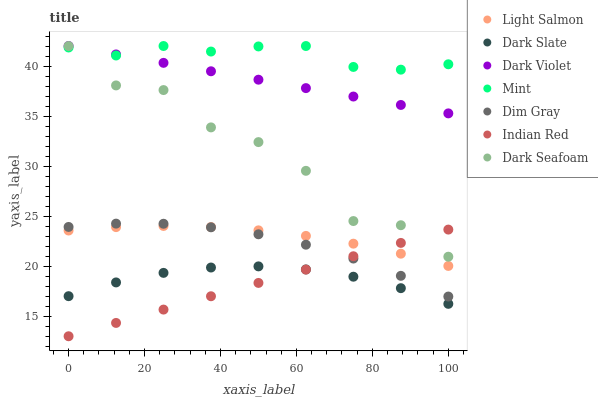Does Indian Red have the minimum area under the curve?
Answer yes or no. Yes. Does Mint have the maximum area under the curve?
Answer yes or no. Yes. Does Dim Gray have the minimum area under the curve?
Answer yes or no. No. Does Dim Gray have the maximum area under the curve?
Answer yes or no. No. Is Indian Red the smoothest?
Answer yes or no. Yes. Is Dark Seafoam the roughest?
Answer yes or no. Yes. Is Dim Gray the smoothest?
Answer yes or no. No. Is Dim Gray the roughest?
Answer yes or no. No. Does Indian Red have the lowest value?
Answer yes or no. Yes. Does Dim Gray have the lowest value?
Answer yes or no. No. Does Mint have the highest value?
Answer yes or no. Yes. Does Dim Gray have the highest value?
Answer yes or no. No. Is Dim Gray less than Dark Seafoam?
Answer yes or no. Yes. Is Dark Seafoam greater than Light Salmon?
Answer yes or no. Yes. Does Dark Violet intersect Mint?
Answer yes or no. Yes. Is Dark Violet less than Mint?
Answer yes or no. No. Is Dark Violet greater than Mint?
Answer yes or no. No. Does Dim Gray intersect Dark Seafoam?
Answer yes or no. No. 